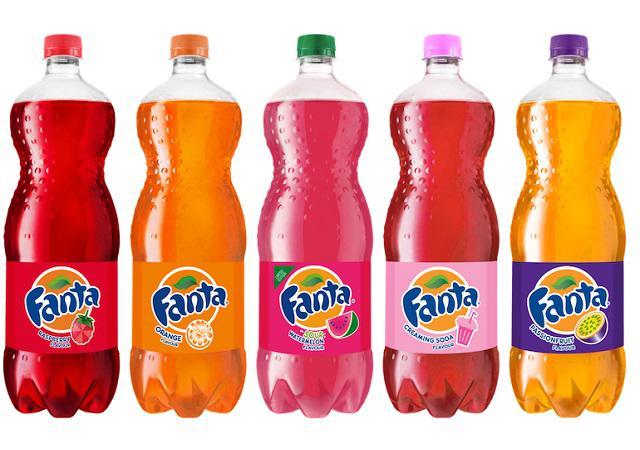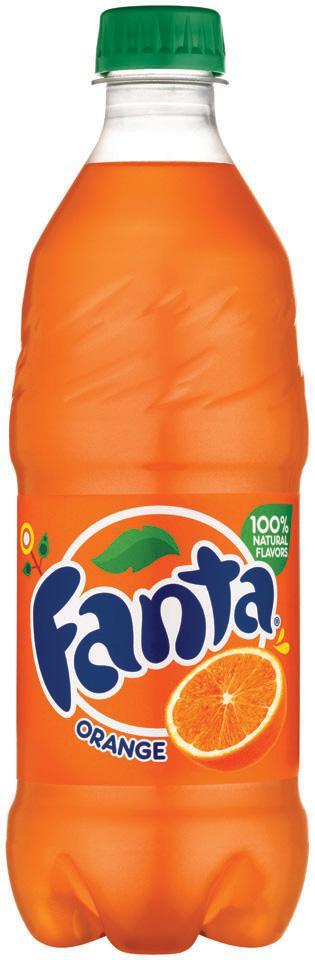The first image is the image on the left, the second image is the image on the right. For the images displayed, is the sentence "One of the images includes fewer than three drink containers." factually correct? Answer yes or no. Yes. The first image is the image on the left, the second image is the image on the right. For the images shown, is this caption "All the containers are plastic." true? Answer yes or no. Yes. 